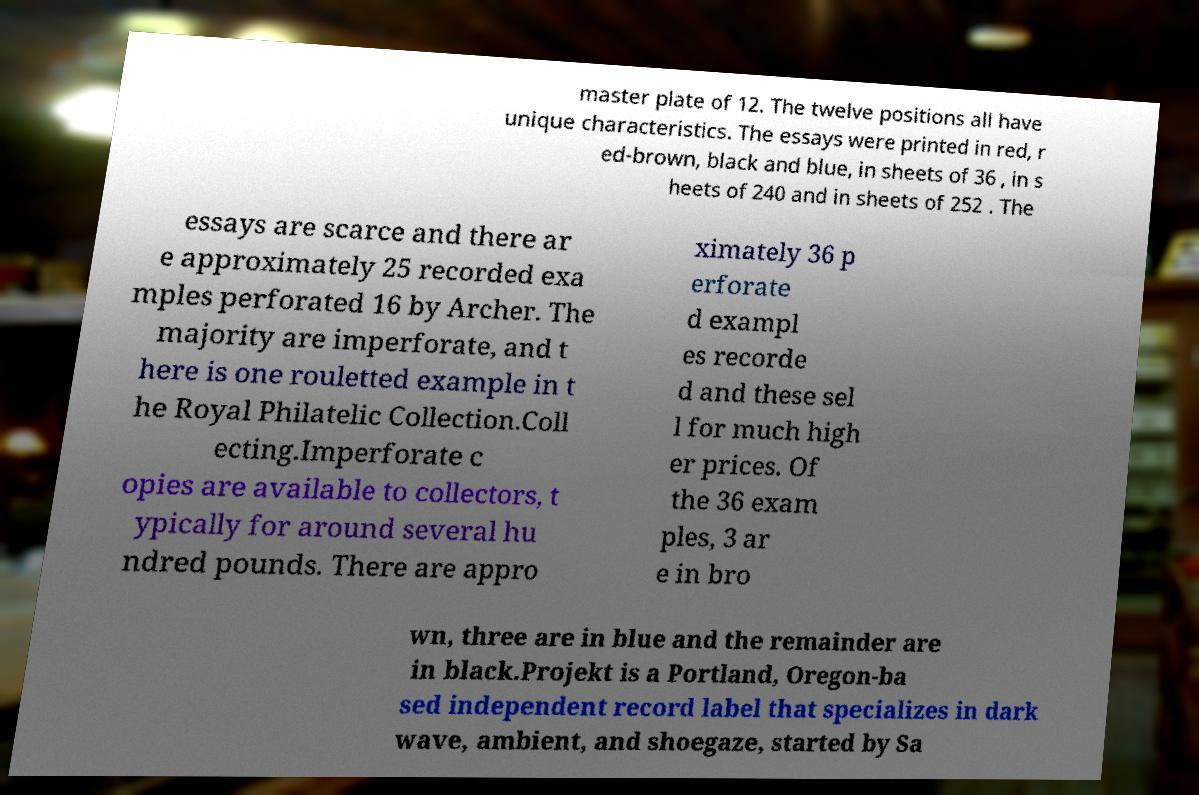What messages or text are displayed in this image? I need them in a readable, typed format. master plate of 12. The twelve positions all have unique characteristics. The essays were printed in red, r ed-brown, black and blue, in sheets of 36 , in s heets of 240 and in sheets of 252 . The essays are scarce and there ar e approximately 25 recorded exa mples perforated 16 by Archer. The majority are imperforate, and t here is one rouletted example in t he Royal Philatelic Collection.Coll ecting.Imperforate c opies are available to collectors, t ypically for around several hu ndred pounds. There are appro ximately 36 p erforate d exampl es recorde d and these sel l for much high er prices. Of the 36 exam ples, 3 ar e in bro wn, three are in blue and the remainder are in black.Projekt is a Portland, Oregon-ba sed independent record label that specializes in dark wave, ambient, and shoegaze, started by Sa 